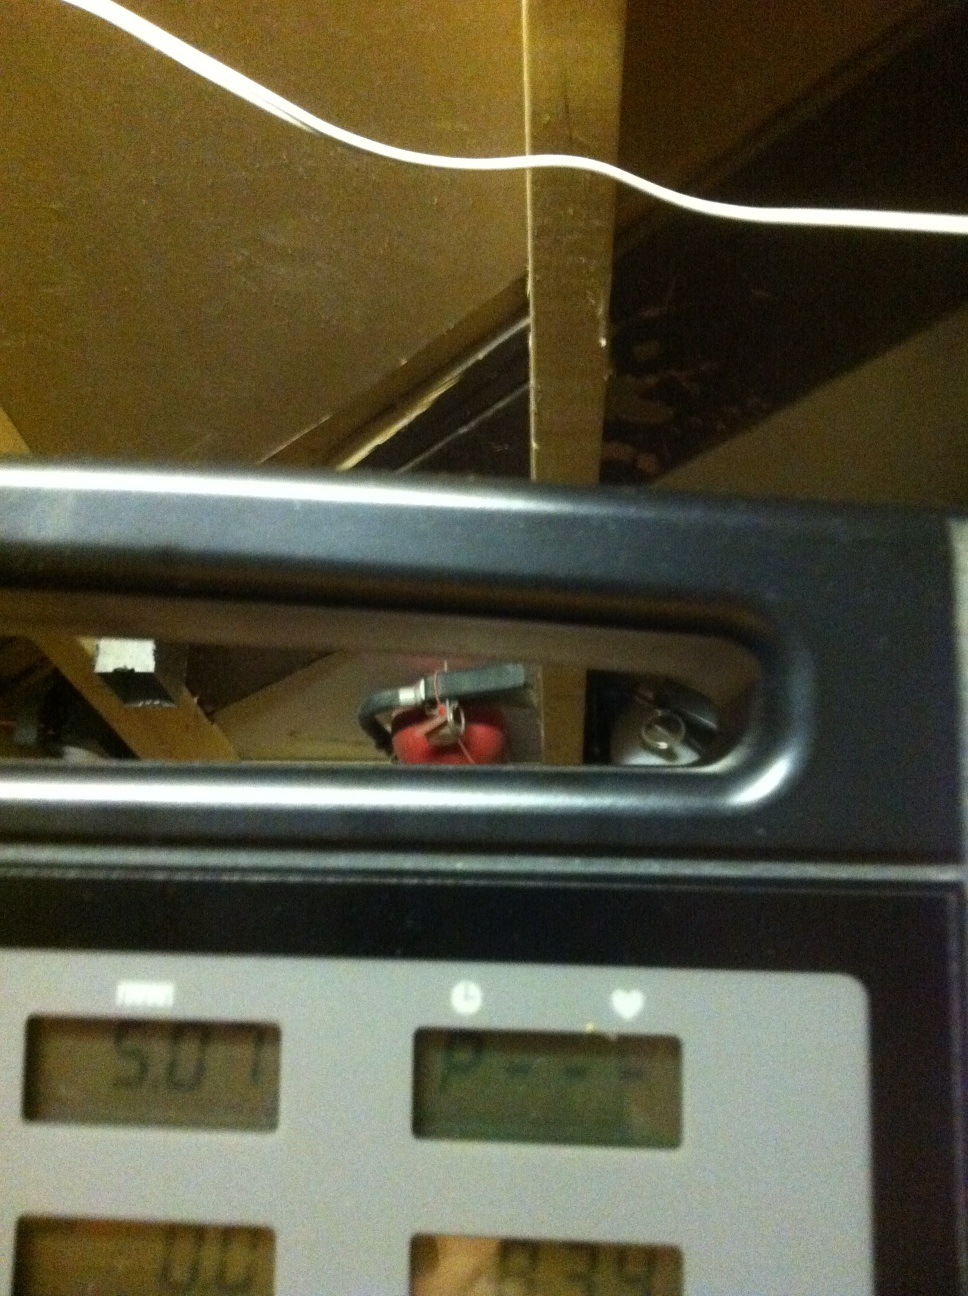How does the current environment shown in the image contribute to an ideal workout experience? The image shows a treadmill set in what appears to be a basement or a secluded area, which can contribute to an ideal workout experience by providing privacy and focusing the individual on their exercise routine without distractions. However, ensuring that the room is well-ventilated and well-lit would be essential to maintain a healthy environment for working out. What might be futuristic exercises on this setup integrating virtual reality? Imagine this treadmill setup integrated with virtual reality could revolutionize workouts. You could jog through simulated environments like a bustling city street, the trails of a serene forest, or along a sunny beach, each offering different resistance and scenery changes. Detailed real-time feedback would gamify workouts, encouraging better performance. Advanced VR could even simulate running on different planets, complete with varied gravities and alien landscapes! This would make each workout session a unique adventure, making exercise engaging and fun. 